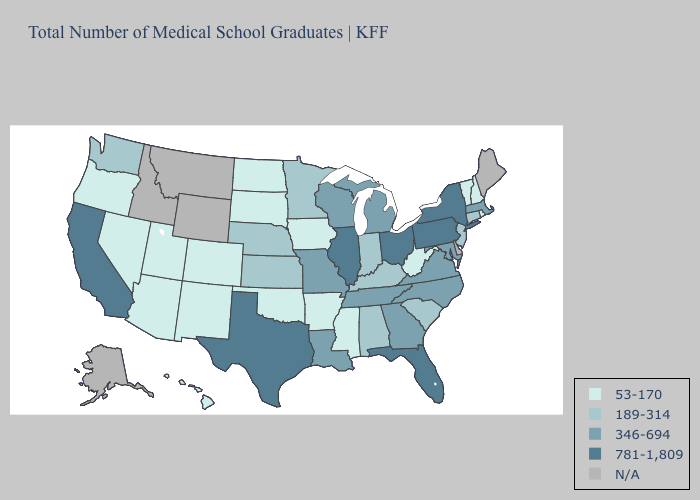Does Virginia have the lowest value in the South?
Concise answer only. No. Among the states that border Massachusetts , which have the highest value?
Give a very brief answer. New York. What is the highest value in the South ?
Write a very short answer. 781-1,809. What is the highest value in the West ?
Concise answer only. 781-1,809. Name the states that have a value in the range N/A?
Short answer required. Alaska, Delaware, Idaho, Maine, Montana, Wyoming. Among the states that border Virginia , which have the highest value?
Keep it brief. Maryland, North Carolina, Tennessee. What is the highest value in the Northeast ?
Give a very brief answer. 781-1,809. What is the value of Pennsylvania?
Quick response, please. 781-1,809. What is the lowest value in the USA?
Answer briefly. 53-170. What is the value of Hawaii?
Keep it brief. 53-170. What is the value of Tennessee?
Write a very short answer. 346-694. 